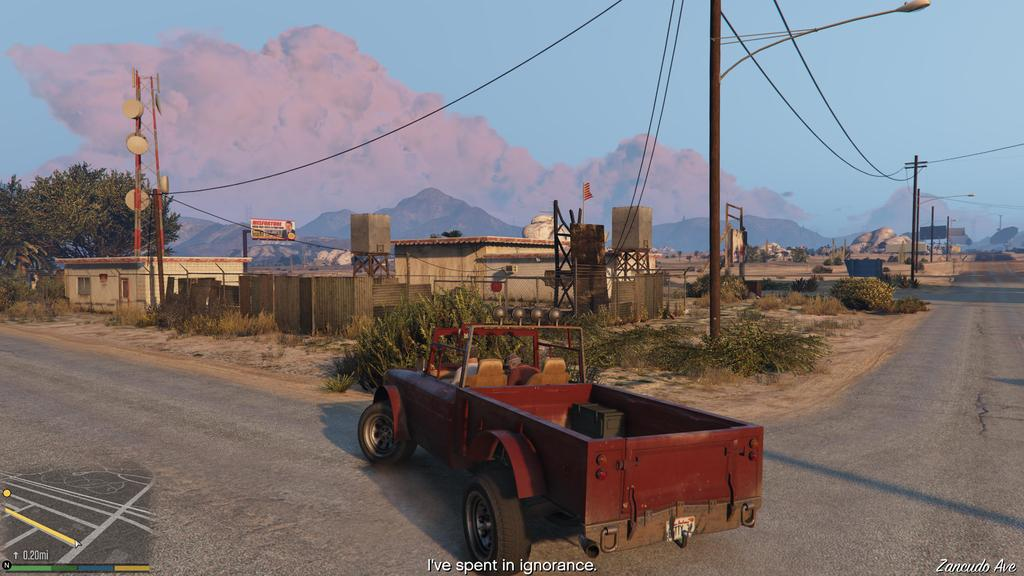What type of structures can be seen in the image? There are houses in the image. What features do the houses have? The houses have windows. What other objects can be seen related to electricity? There are current poles and wires present in the image. What type of poles are used for lighting? There are light poles in the image. What tall structure is visible in the image? There is a tower in the image. What natural features can be seen in the image? Mountains and trees are visible in the image. What part of the sky is visible? The sky is visible in the image. What mode of transportation can be seen on the road? There is a vehicle on the road in the image. How many slaves are visible in the image? There are no slaves present in the image. What type of seat can be seen on the tower in the image? There is no seat visible on the tower in the image. 